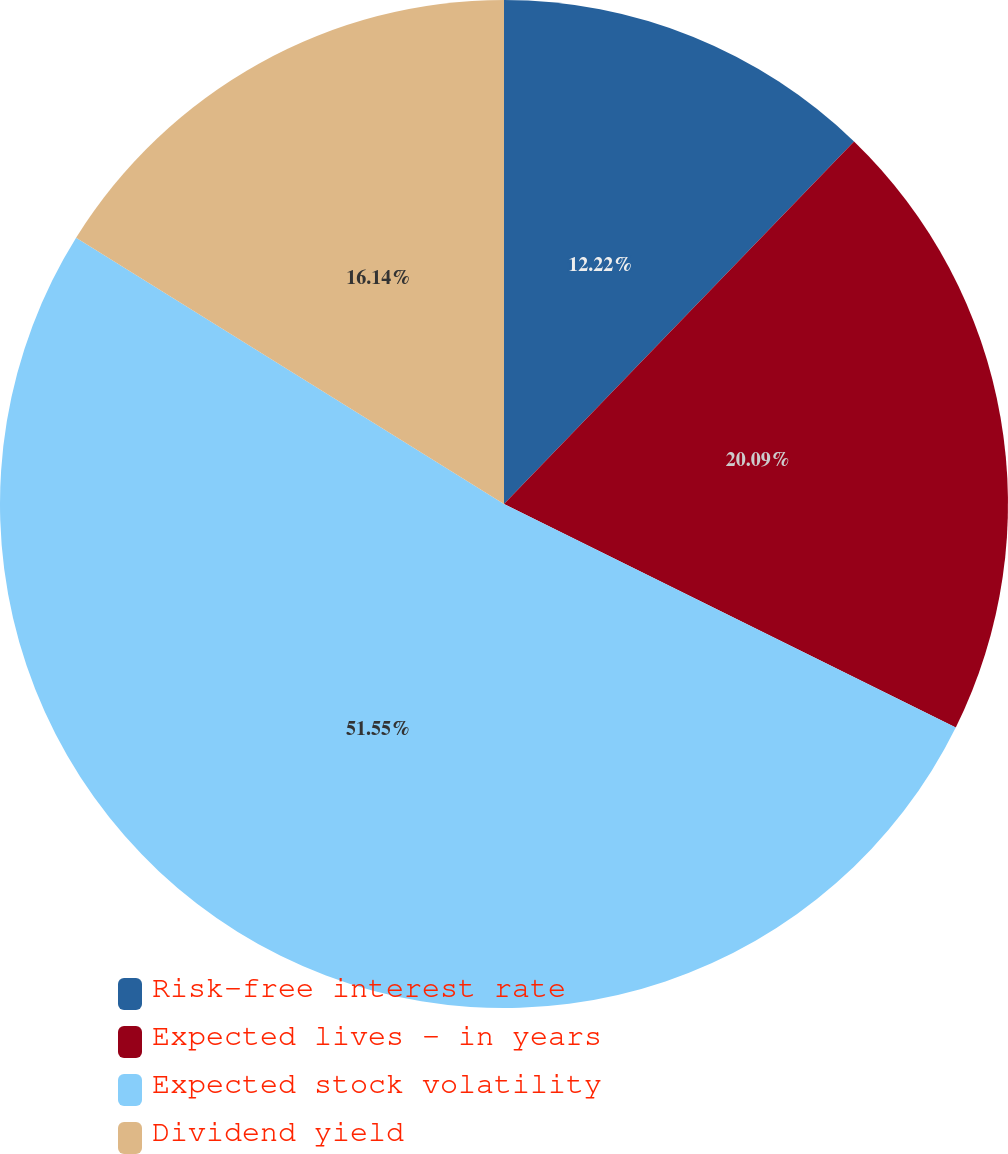Convert chart. <chart><loc_0><loc_0><loc_500><loc_500><pie_chart><fcel>Risk-free interest rate<fcel>Expected lives - in years<fcel>Expected stock volatility<fcel>Dividend yield<nl><fcel>12.22%<fcel>20.09%<fcel>51.55%<fcel>16.14%<nl></chart> 